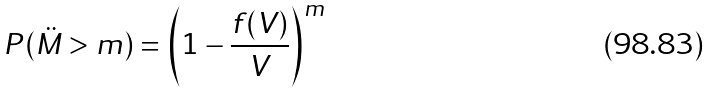<formula> <loc_0><loc_0><loc_500><loc_500>P ( \ddot { M } > m ) = \left ( 1 - \frac { f ( V ) } { V } \right ) ^ { m }</formula> 